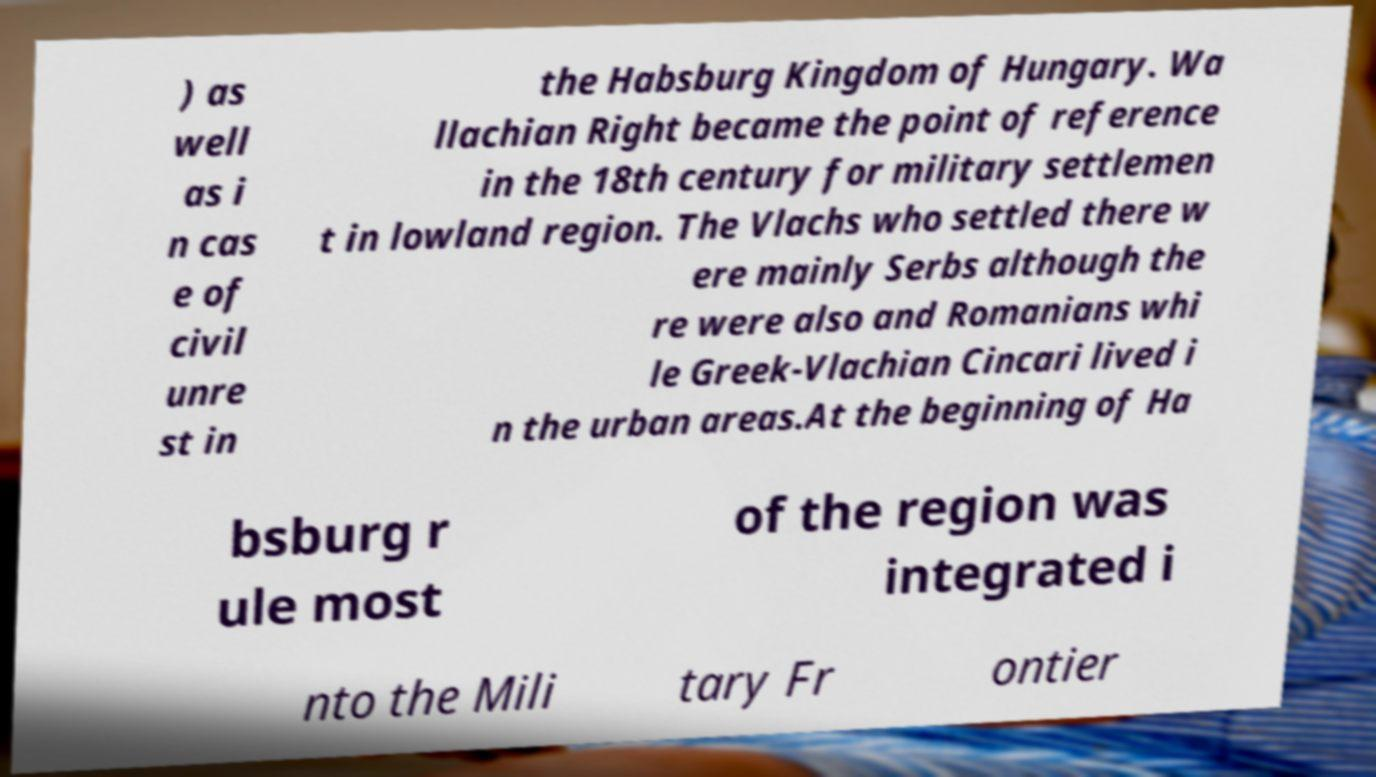Could you assist in decoding the text presented in this image and type it out clearly? ) as well as i n cas e of civil unre st in the Habsburg Kingdom of Hungary. Wa llachian Right became the point of reference in the 18th century for military settlemen t in lowland region. The Vlachs who settled there w ere mainly Serbs although the re were also and Romanians whi le Greek-Vlachian Cincari lived i n the urban areas.At the beginning of Ha bsburg r ule most of the region was integrated i nto the Mili tary Fr ontier 